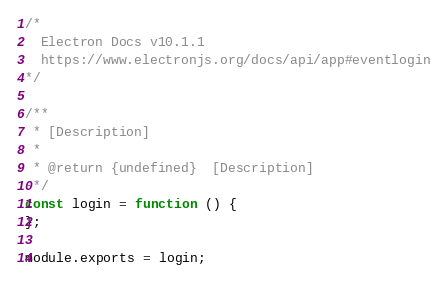<code> <loc_0><loc_0><loc_500><loc_500><_JavaScript_>
/*
  Electron Docs v10.1.1
  https://www.electronjs.org/docs/api/app#eventlogin
*/

/**
 * [Description]
 *
 * @return {undefined}  [Description]
 */
const login = function () {
};

module.exports = login;
</code> 